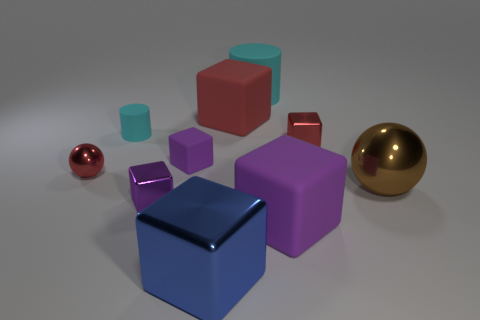Subtract all small red cubes. How many cubes are left? 5 Subtract all red balls. How many balls are left? 1 Subtract all blocks. How many objects are left? 4 Subtract 1 cylinders. How many cylinders are left? 1 Add 9 big red matte things. How many big red matte things are left? 10 Add 1 tiny purple matte cubes. How many tiny purple matte cubes exist? 2 Subtract 3 purple blocks. How many objects are left? 7 Subtract all blue balls. Subtract all purple blocks. How many balls are left? 2 Subtract all brown balls. How many purple blocks are left? 3 Subtract all big green shiny cylinders. Subtract all tiny rubber cubes. How many objects are left? 9 